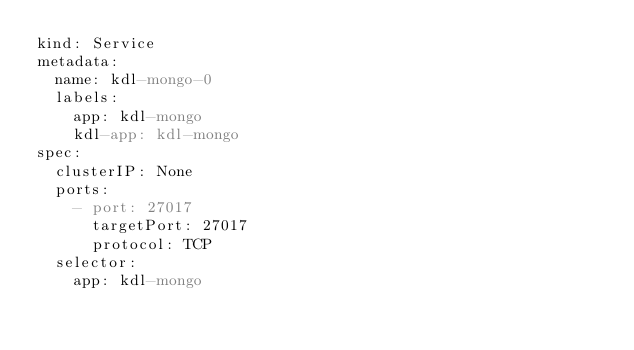Convert code to text. <code><loc_0><loc_0><loc_500><loc_500><_YAML_>kind: Service
metadata:
  name: kdl-mongo-0
  labels:
    app: kdl-mongo
    kdl-app: kdl-mongo
spec:
  clusterIP: None
  ports:
    - port: 27017
      targetPort: 27017
      protocol: TCP
  selector:
    app: kdl-mongo
</code> 